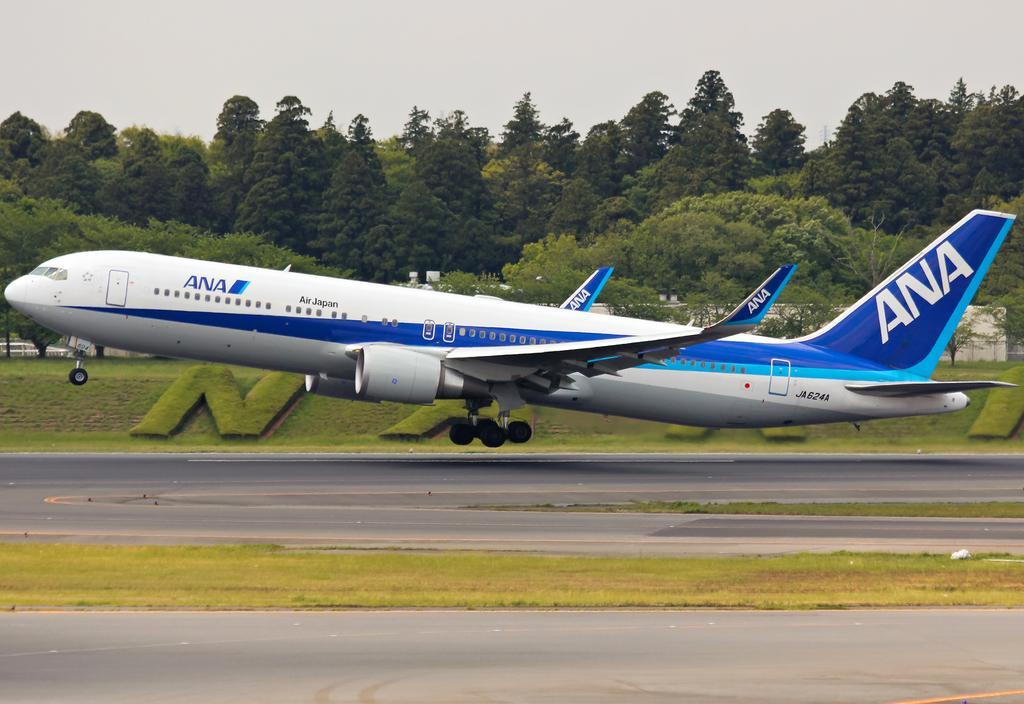Please provide a concise description of this image. In the image there is an airplane taking off on road with grassland on either side of it and in the back there are trees all over the image and above its sky. 